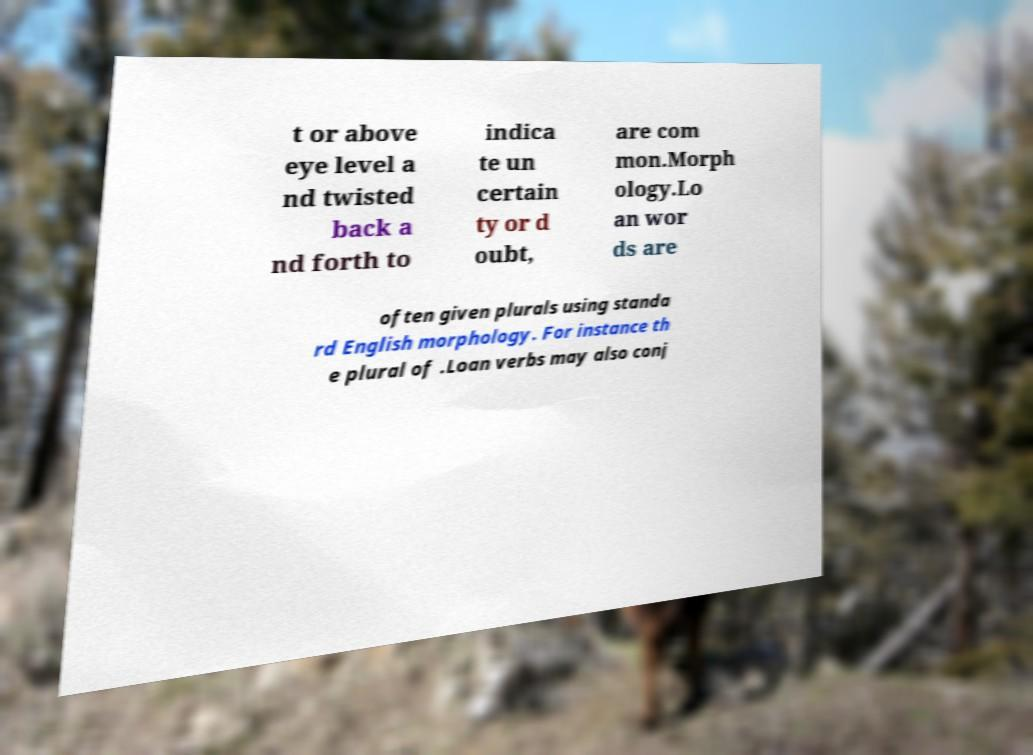Could you assist in decoding the text presented in this image and type it out clearly? t or above eye level a nd twisted back a nd forth to indica te un certain ty or d oubt, are com mon.Morph ology.Lo an wor ds are often given plurals using standa rd English morphology. For instance th e plural of .Loan verbs may also conj 